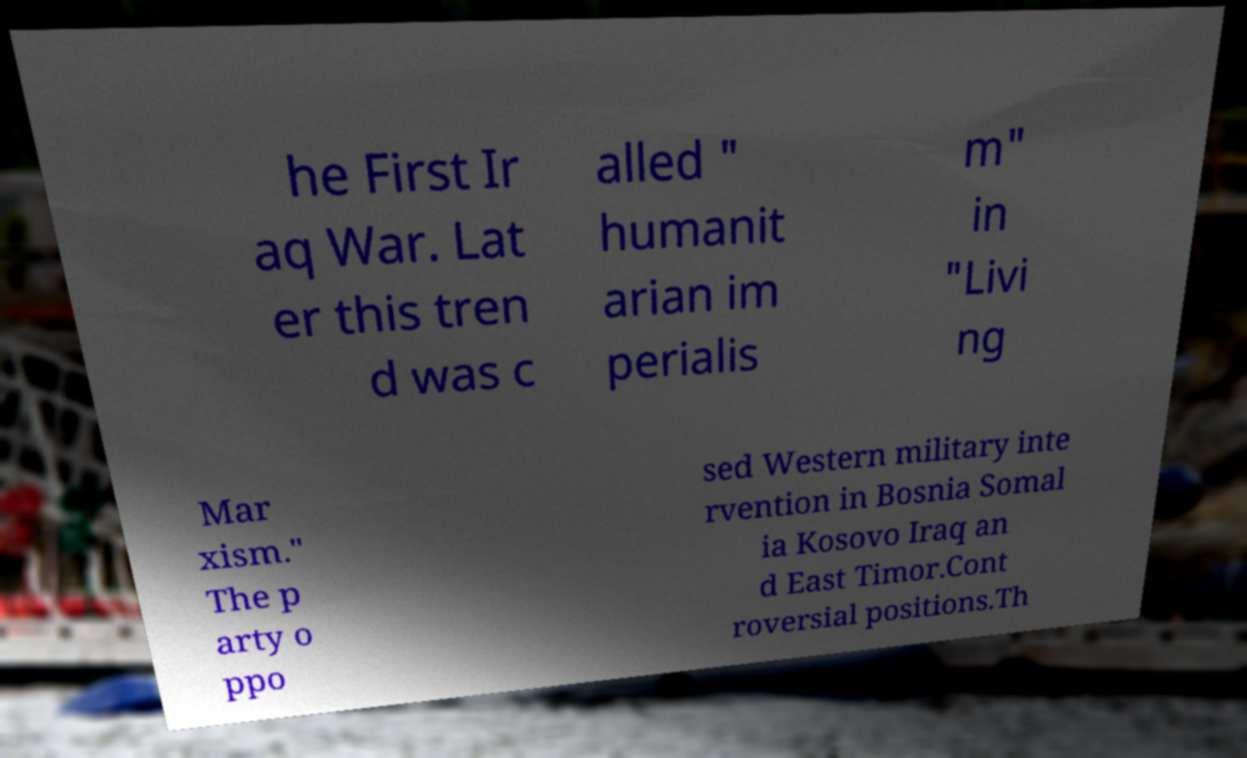Could you assist in decoding the text presented in this image and type it out clearly? he First Ir aq War. Lat er this tren d was c alled " humanit arian im perialis m" in "Livi ng Mar xism." The p arty o ppo sed Western military inte rvention in Bosnia Somal ia Kosovo Iraq an d East Timor.Cont roversial positions.Th 